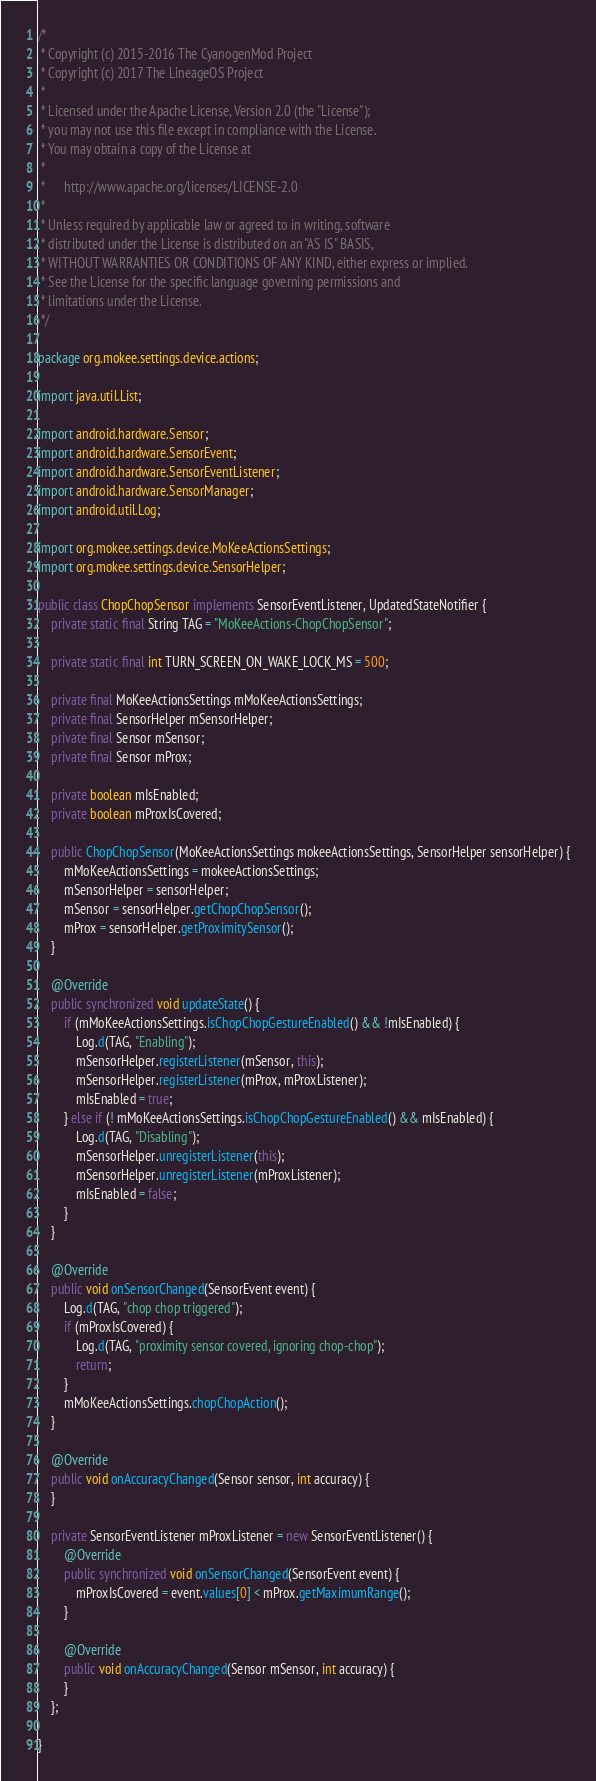Convert code to text. <code><loc_0><loc_0><loc_500><loc_500><_Java_>/*
 * Copyright (c) 2015-2016 The CyanogenMod Project
 * Copyright (c) 2017 The LineageOS Project
 *
 * Licensed under the Apache License, Version 2.0 (the "License");
 * you may not use this file except in compliance with the License.
 * You may obtain a copy of the License at
 *
 *      http://www.apache.org/licenses/LICENSE-2.0
 *
 * Unless required by applicable law or agreed to in writing, software
 * distributed under the License is distributed on an "AS IS" BASIS,
 * WITHOUT WARRANTIES OR CONDITIONS OF ANY KIND, either express or implied.
 * See the License for the specific language governing permissions and
 * limitations under the License.
 */

package org.mokee.settings.device.actions;

import java.util.List;

import android.hardware.Sensor;
import android.hardware.SensorEvent;
import android.hardware.SensorEventListener;
import android.hardware.SensorManager;
import android.util.Log;

import org.mokee.settings.device.MoKeeActionsSettings;
import org.mokee.settings.device.SensorHelper;

public class ChopChopSensor implements SensorEventListener, UpdatedStateNotifier {
    private static final String TAG = "MoKeeActions-ChopChopSensor";

    private static final int TURN_SCREEN_ON_WAKE_LOCK_MS = 500;

    private final MoKeeActionsSettings mMoKeeActionsSettings;
    private final SensorHelper mSensorHelper;
    private final Sensor mSensor;
    private final Sensor mProx;

    private boolean mIsEnabled;
    private boolean mProxIsCovered;

    public ChopChopSensor(MoKeeActionsSettings mokeeActionsSettings, SensorHelper sensorHelper) {
        mMoKeeActionsSettings = mokeeActionsSettings;
        mSensorHelper = sensorHelper;
        mSensor = sensorHelper.getChopChopSensor();
        mProx = sensorHelper.getProximitySensor();
    }

    @Override
    public synchronized void updateState() {
        if (mMoKeeActionsSettings.isChopChopGestureEnabled() && !mIsEnabled) {
            Log.d(TAG, "Enabling");
            mSensorHelper.registerListener(mSensor, this);
            mSensorHelper.registerListener(mProx, mProxListener);
            mIsEnabled = true;
        } else if (! mMoKeeActionsSettings.isChopChopGestureEnabled() && mIsEnabled) {
            Log.d(TAG, "Disabling");
            mSensorHelper.unregisterListener(this);
            mSensorHelper.unregisterListener(mProxListener);
            mIsEnabled = false;
        }
    }

    @Override
    public void onSensorChanged(SensorEvent event) {
        Log.d(TAG, "chop chop triggered");
        if (mProxIsCovered) {
            Log.d(TAG, "proximity sensor covered, ignoring chop-chop");
            return;
        }
        mMoKeeActionsSettings.chopChopAction();
    }

    @Override
    public void onAccuracyChanged(Sensor sensor, int accuracy) {
    }

    private SensorEventListener mProxListener = new SensorEventListener() {
        @Override
        public synchronized void onSensorChanged(SensorEvent event) {
            mProxIsCovered = event.values[0] < mProx.getMaximumRange();
        }

        @Override
        public void onAccuracyChanged(Sensor mSensor, int accuracy) {
        }
    };

}
</code> 